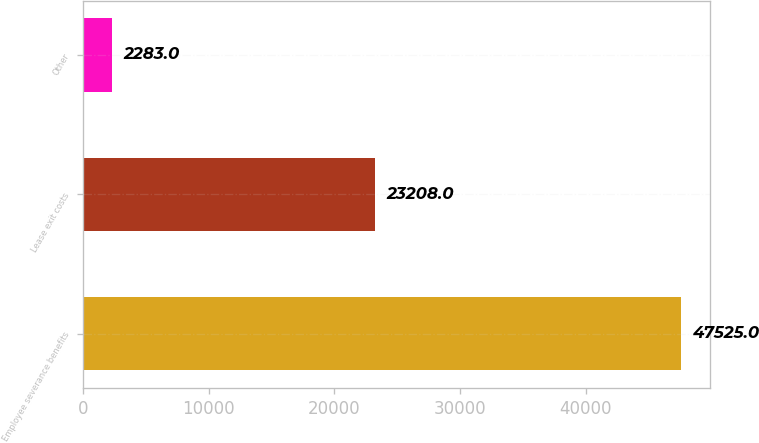Convert chart to OTSL. <chart><loc_0><loc_0><loc_500><loc_500><bar_chart><fcel>Employee severance benefits<fcel>Lease exit costs<fcel>Other<nl><fcel>47525<fcel>23208<fcel>2283<nl></chart> 